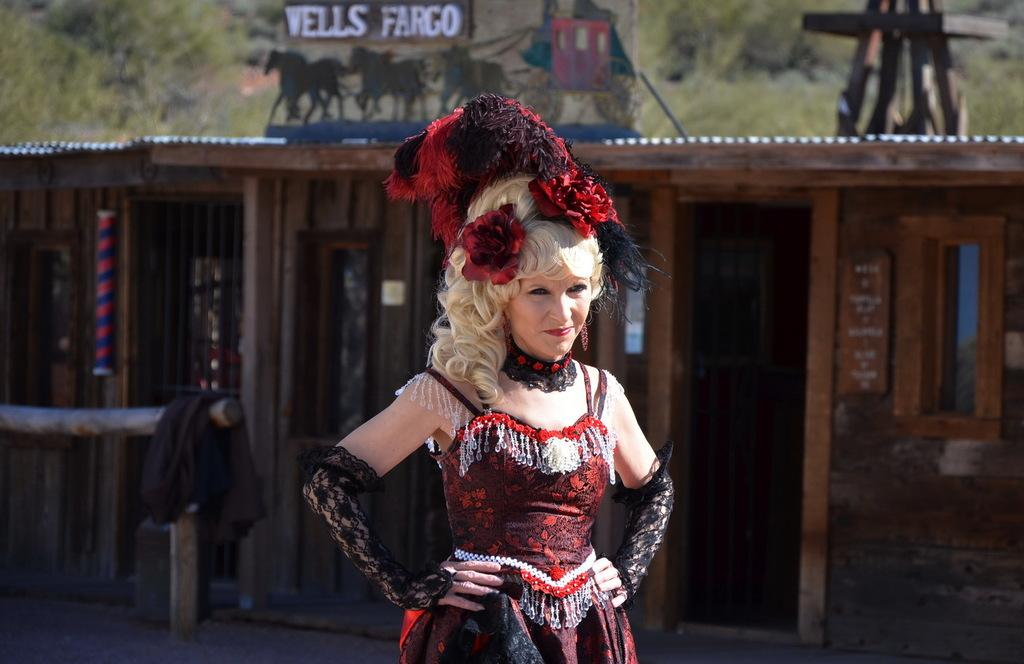What is the main subject of the image? There is a woman standing in the image. What is the woman wearing? The woman is wearing a costume. Can you describe any other objects or structures in the image? There is a shade, a cloth on a wooden pole, and a board in the image. How would you describe the background of the image? The background of the image is blurry, but trees are visible. How many jellyfish can be seen swimming in the image? There are no jellyfish present in the image. What type of brake is visible on the woman's costume? There is no brake visible on the woman's costume, as it is a costume and not a vehicle. 